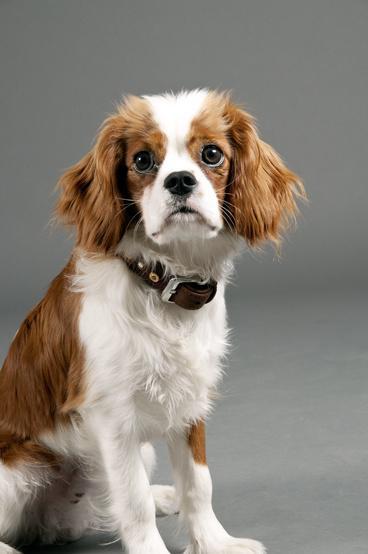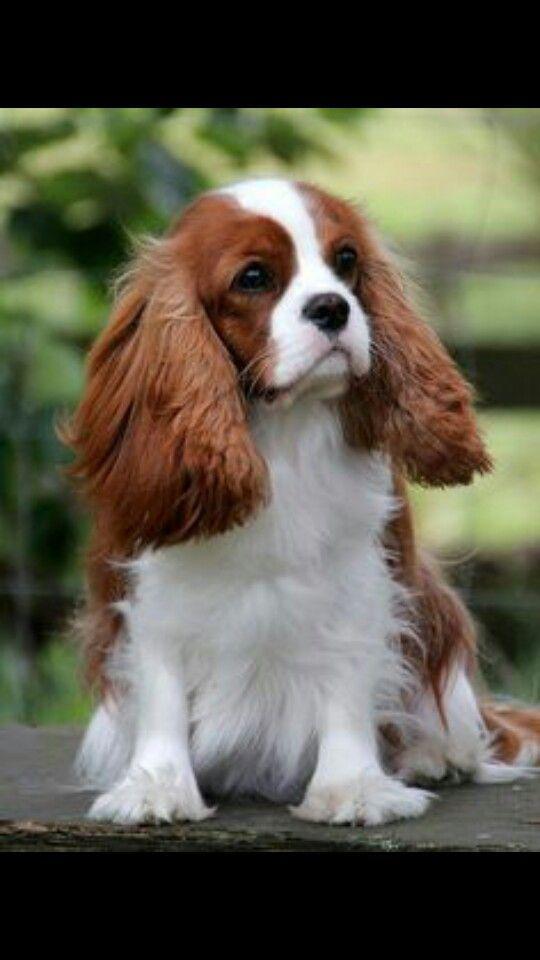The first image is the image on the left, the second image is the image on the right. Examine the images to the left and right. Is the description "There are two Cavalier King Charles Spaniels that are sitting." accurate? Answer yes or no. Yes. 